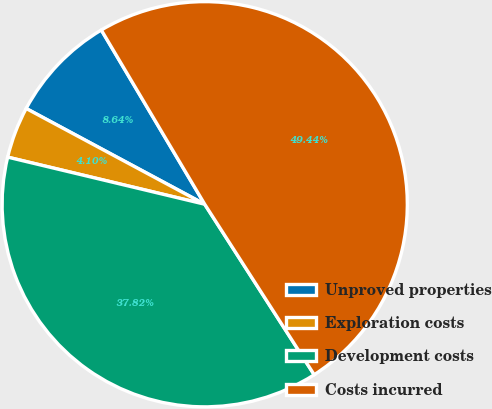Convert chart. <chart><loc_0><loc_0><loc_500><loc_500><pie_chart><fcel>Unproved properties<fcel>Exploration costs<fcel>Development costs<fcel>Costs incurred<nl><fcel>8.64%<fcel>4.1%<fcel>37.82%<fcel>49.44%<nl></chart> 